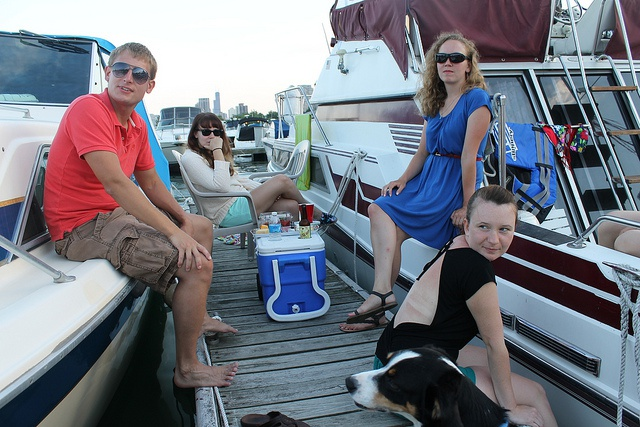Describe the objects in this image and their specific colors. I can see boat in white, black, gray, and darkgray tones, boat in white, lightgray, black, gray, and blue tones, people in white, gray, salmon, and brown tones, people in white, blue, gray, and navy tones, and people in white, black, darkgray, and gray tones in this image. 